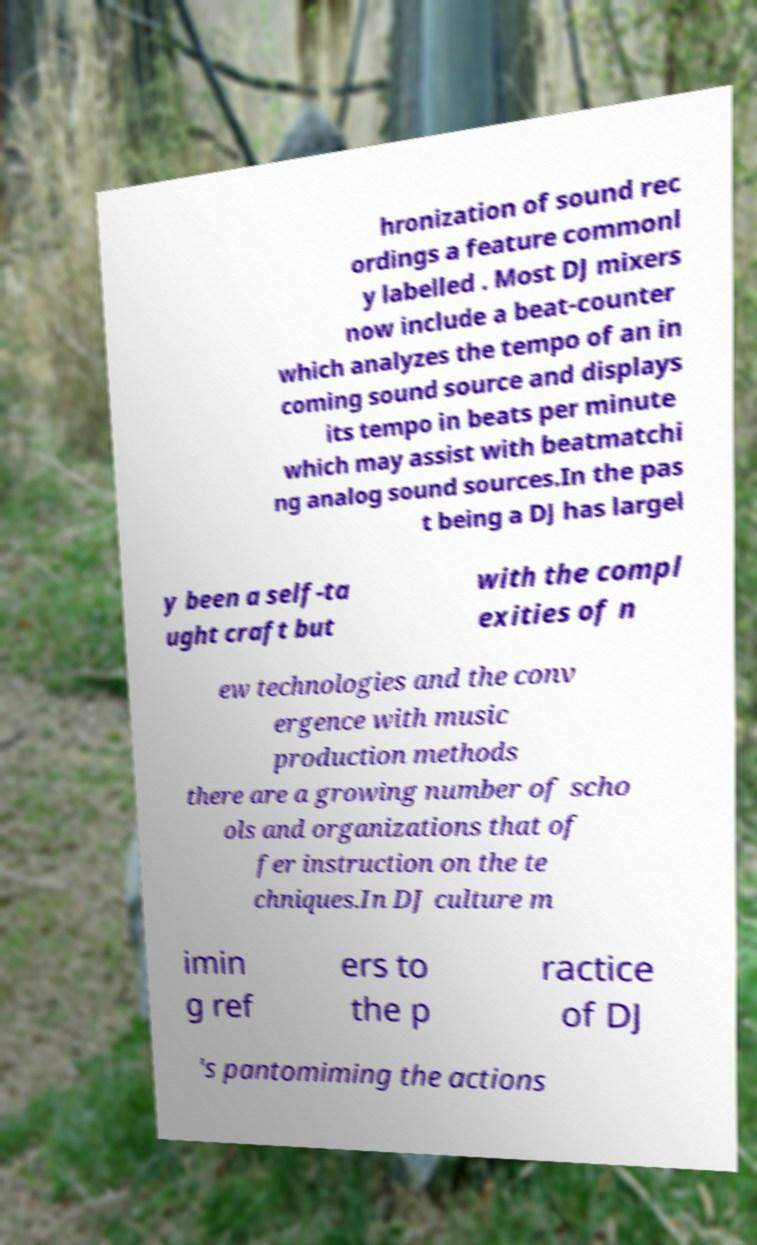There's text embedded in this image that I need extracted. Can you transcribe it verbatim? hronization of sound rec ordings a feature commonl y labelled . Most DJ mixers now include a beat-counter which analyzes the tempo of an in coming sound source and displays its tempo in beats per minute which may assist with beatmatchi ng analog sound sources.In the pas t being a DJ has largel y been a self-ta ught craft but with the compl exities of n ew technologies and the conv ergence with music production methods there are a growing number of scho ols and organizations that of fer instruction on the te chniques.In DJ culture m imin g ref ers to the p ractice of DJ 's pantomiming the actions 